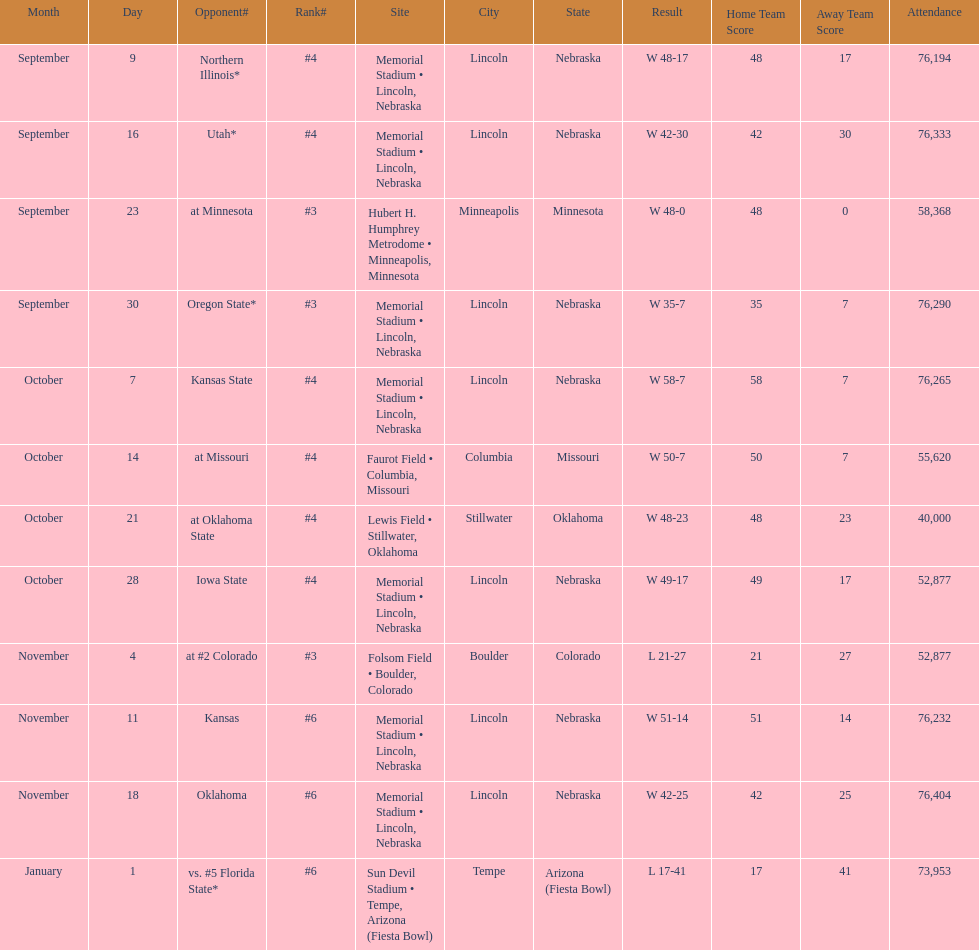What is the next site listed after lewis field? Memorial Stadium • Lincoln, Nebraska. 